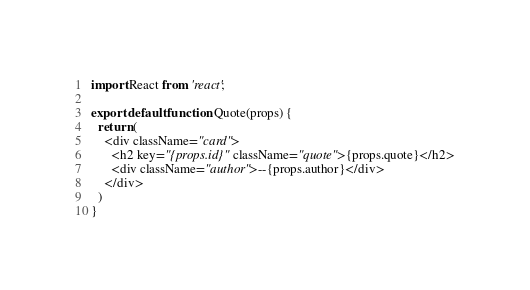Convert code to text. <code><loc_0><loc_0><loc_500><loc_500><_JavaScript_>import React from 'react';

export default function Quote(props) {
  return (
    <div className="card">
      <h2 key="{props.id}" className="quote">{props.quote}</h2>
      <div className="author">--{props.author}</div>
    </div>
  )
}
</code> 